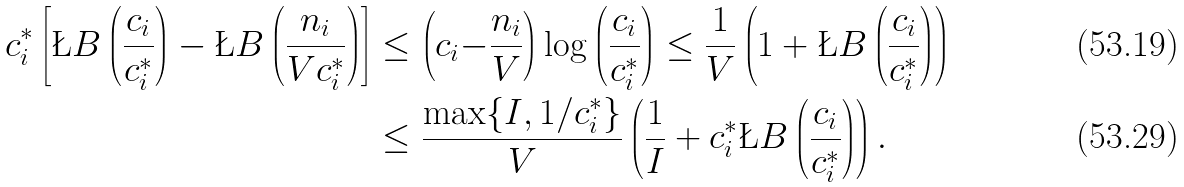<formula> <loc_0><loc_0><loc_500><loc_500>c _ { i } ^ { * } \left [ \L B \left ( \frac { c _ { i } } { c _ { i } ^ { * } } \right ) - \L B \left ( \frac { n _ { i } } { V c _ { i } ^ { * } } \right ) \right ] & \leq \left ( c _ { i } { - } \frac { n _ { i } } { V } \right ) \log \left ( \frac { c _ { i } } { c _ { i } ^ { * } } \right ) \leq \frac { 1 } { V } \left ( 1 + \L B \left ( \frac { c _ { i } } { c ^ { * } _ { i } } \right ) \right ) \\ & \leq \frac { \max \{ I , 1 / c ^ { * } _ { i } \} } V \left ( \frac { 1 } { I } + c ^ { * } _ { i } \L B \left ( \frac { c _ { i } } { c ^ { * } _ { i } } \right ) \right ) .</formula> 